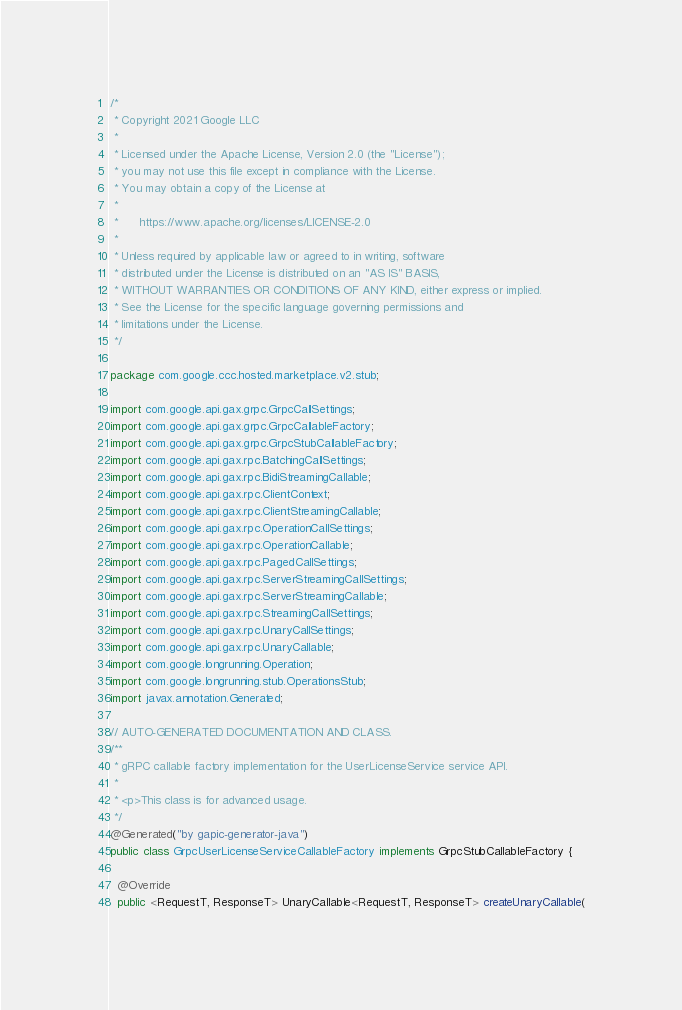Convert code to text. <code><loc_0><loc_0><loc_500><loc_500><_Java_>/*
 * Copyright 2021 Google LLC
 *
 * Licensed under the Apache License, Version 2.0 (the "License");
 * you may not use this file except in compliance with the License.
 * You may obtain a copy of the License at
 *
 *      https://www.apache.org/licenses/LICENSE-2.0
 *
 * Unless required by applicable law or agreed to in writing, software
 * distributed under the License is distributed on an "AS IS" BASIS,
 * WITHOUT WARRANTIES OR CONDITIONS OF ANY KIND, either express or implied.
 * See the License for the specific language governing permissions and
 * limitations under the License.
 */

package com.google.ccc.hosted.marketplace.v2.stub;

import com.google.api.gax.grpc.GrpcCallSettings;
import com.google.api.gax.grpc.GrpcCallableFactory;
import com.google.api.gax.grpc.GrpcStubCallableFactory;
import com.google.api.gax.rpc.BatchingCallSettings;
import com.google.api.gax.rpc.BidiStreamingCallable;
import com.google.api.gax.rpc.ClientContext;
import com.google.api.gax.rpc.ClientStreamingCallable;
import com.google.api.gax.rpc.OperationCallSettings;
import com.google.api.gax.rpc.OperationCallable;
import com.google.api.gax.rpc.PagedCallSettings;
import com.google.api.gax.rpc.ServerStreamingCallSettings;
import com.google.api.gax.rpc.ServerStreamingCallable;
import com.google.api.gax.rpc.StreamingCallSettings;
import com.google.api.gax.rpc.UnaryCallSettings;
import com.google.api.gax.rpc.UnaryCallable;
import com.google.longrunning.Operation;
import com.google.longrunning.stub.OperationsStub;
import javax.annotation.Generated;

// AUTO-GENERATED DOCUMENTATION AND CLASS.
/**
 * gRPC callable factory implementation for the UserLicenseService service API.
 *
 * <p>This class is for advanced usage.
 */
@Generated("by gapic-generator-java")
public class GrpcUserLicenseServiceCallableFactory implements GrpcStubCallableFactory {

  @Override
  public <RequestT, ResponseT> UnaryCallable<RequestT, ResponseT> createUnaryCallable(</code> 